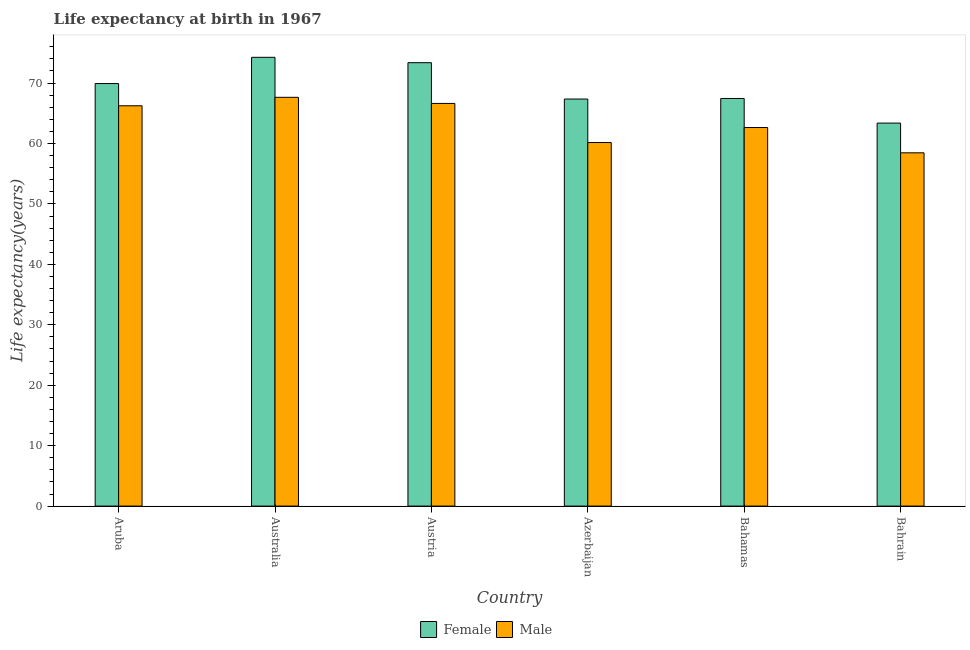How many groups of bars are there?
Offer a terse response. 6. Are the number of bars on each tick of the X-axis equal?
Your response must be concise. Yes. How many bars are there on the 6th tick from the right?
Your response must be concise. 2. What is the label of the 1st group of bars from the left?
Offer a very short reply. Aruba. What is the life expectancy(female) in Austria?
Give a very brief answer. 73.37. Across all countries, what is the maximum life expectancy(male)?
Make the answer very short. 67.64. Across all countries, what is the minimum life expectancy(male)?
Provide a short and direct response. 58.46. In which country was the life expectancy(male) maximum?
Ensure brevity in your answer.  Australia. In which country was the life expectancy(female) minimum?
Keep it short and to the point. Bahrain. What is the total life expectancy(female) in the graph?
Provide a succinct answer. 415.73. What is the difference between the life expectancy(female) in Austria and that in Azerbaijan?
Keep it short and to the point. 6.02. What is the difference between the life expectancy(male) in Aruba and the life expectancy(female) in Austria?
Provide a succinct answer. -7.13. What is the average life expectancy(male) per country?
Provide a succinct answer. 63.63. What is the difference between the life expectancy(female) and life expectancy(male) in Bahamas?
Provide a succinct answer. 4.81. In how many countries, is the life expectancy(female) greater than 34 years?
Your response must be concise. 6. What is the ratio of the life expectancy(female) in Austria to that in Azerbaijan?
Ensure brevity in your answer.  1.09. Is the difference between the life expectancy(female) in Azerbaijan and Bahamas greater than the difference between the life expectancy(male) in Azerbaijan and Bahamas?
Make the answer very short. Yes. What is the difference between the highest and the second highest life expectancy(female)?
Keep it short and to the point. 0.89. What is the difference between the highest and the lowest life expectancy(male)?
Keep it short and to the point. 9.18. In how many countries, is the life expectancy(male) greater than the average life expectancy(male) taken over all countries?
Offer a very short reply. 3. Is the sum of the life expectancy(male) in Aruba and Bahamas greater than the maximum life expectancy(female) across all countries?
Keep it short and to the point. Yes. How many bars are there?
Your answer should be compact. 12. How many countries are there in the graph?
Provide a succinct answer. 6. Does the graph contain any zero values?
Provide a succinct answer. No. Where does the legend appear in the graph?
Make the answer very short. Bottom center. How are the legend labels stacked?
Your answer should be very brief. Horizontal. What is the title of the graph?
Make the answer very short. Life expectancy at birth in 1967. What is the label or title of the X-axis?
Your answer should be very brief. Country. What is the label or title of the Y-axis?
Provide a succinct answer. Life expectancy(years). What is the Life expectancy(years) in Female in Aruba?
Keep it short and to the point. 69.92. What is the Life expectancy(years) of Male in Aruba?
Provide a short and direct response. 66.24. What is the Life expectancy(years) of Female in Australia?
Give a very brief answer. 74.26. What is the Life expectancy(years) in Male in Australia?
Ensure brevity in your answer.  67.64. What is the Life expectancy(years) of Female in Austria?
Provide a succinct answer. 73.37. What is the Life expectancy(years) in Male in Austria?
Your answer should be very brief. 66.63. What is the Life expectancy(years) in Female in Azerbaijan?
Ensure brevity in your answer.  67.36. What is the Life expectancy(years) in Male in Azerbaijan?
Provide a succinct answer. 60.16. What is the Life expectancy(years) in Female in Bahamas?
Make the answer very short. 67.45. What is the Life expectancy(years) in Male in Bahamas?
Your answer should be very brief. 62.64. What is the Life expectancy(years) in Female in Bahrain?
Your answer should be compact. 63.38. What is the Life expectancy(years) of Male in Bahrain?
Your response must be concise. 58.46. Across all countries, what is the maximum Life expectancy(years) of Female?
Offer a very short reply. 74.26. Across all countries, what is the maximum Life expectancy(years) of Male?
Your answer should be compact. 67.64. Across all countries, what is the minimum Life expectancy(years) in Female?
Ensure brevity in your answer.  63.38. Across all countries, what is the minimum Life expectancy(years) of Male?
Provide a succinct answer. 58.46. What is the total Life expectancy(years) of Female in the graph?
Make the answer very short. 415.73. What is the total Life expectancy(years) of Male in the graph?
Offer a terse response. 381.77. What is the difference between the Life expectancy(years) of Female in Aruba and that in Australia?
Offer a very short reply. -4.34. What is the difference between the Life expectancy(years) in Male in Aruba and that in Australia?
Make the answer very short. -1.4. What is the difference between the Life expectancy(years) of Female in Aruba and that in Austria?
Ensure brevity in your answer.  -3.45. What is the difference between the Life expectancy(years) in Male in Aruba and that in Austria?
Provide a succinct answer. -0.39. What is the difference between the Life expectancy(years) in Female in Aruba and that in Azerbaijan?
Your response must be concise. 2.56. What is the difference between the Life expectancy(years) of Male in Aruba and that in Azerbaijan?
Offer a very short reply. 6.08. What is the difference between the Life expectancy(years) in Female in Aruba and that in Bahamas?
Offer a terse response. 2.47. What is the difference between the Life expectancy(years) of Male in Aruba and that in Bahamas?
Provide a succinct answer. 3.6. What is the difference between the Life expectancy(years) in Female in Aruba and that in Bahrain?
Your answer should be compact. 6.54. What is the difference between the Life expectancy(years) of Male in Aruba and that in Bahrain?
Offer a terse response. 7.78. What is the difference between the Life expectancy(years) of Female in Australia and that in Austria?
Give a very brief answer. 0.89. What is the difference between the Life expectancy(years) of Female in Australia and that in Azerbaijan?
Provide a short and direct response. 6.91. What is the difference between the Life expectancy(years) of Male in Australia and that in Azerbaijan?
Your answer should be compact. 7.48. What is the difference between the Life expectancy(years) of Female in Australia and that in Bahamas?
Your answer should be very brief. 6.81. What is the difference between the Life expectancy(years) in Male in Australia and that in Bahamas?
Make the answer very short. 5. What is the difference between the Life expectancy(years) in Female in Australia and that in Bahrain?
Offer a terse response. 10.88. What is the difference between the Life expectancy(years) in Male in Australia and that in Bahrain?
Keep it short and to the point. 9.18. What is the difference between the Life expectancy(years) of Female in Austria and that in Azerbaijan?
Give a very brief answer. 6.01. What is the difference between the Life expectancy(years) in Male in Austria and that in Azerbaijan?
Your response must be concise. 6.47. What is the difference between the Life expectancy(years) of Female in Austria and that in Bahamas?
Ensure brevity in your answer.  5.92. What is the difference between the Life expectancy(years) in Male in Austria and that in Bahamas?
Offer a terse response. 3.99. What is the difference between the Life expectancy(years) in Female in Austria and that in Bahrain?
Your answer should be compact. 9.99. What is the difference between the Life expectancy(years) in Male in Austria and that in Bahrain?
Your answer should be very brief. 8.17. What is the difference between the Life expectancy(years) of Female in Azerbaijan and that in Bahamas?
Your response must be concise. -0.09. What is the difference between the Life expectancy(years) of Male in Azerbaijan and that in Bahamas?
Provide a succinct answer. -2.48. What is the difference between the Life expectancy(years) in Female in Azerbaijan and that in Bahrain?
Provide a short and direct response. 3.98. What is the difference between the Life expectancy(years) of Female in Bahamas and that in Bahrain?
Your response must be concise. 4.07. What is the difference between the Life expectancy(years) of Male in Bahamas and that in Bahrain?
Offer a terse response. 4.18. What is the difference between the Life expectancy(years) in Female in Aruba and the Life expectancy(years) in Male in Australia?
Your response must be concise. 2.28. What is the difference between the Life expectancy(years) of Female in Aruba and the Life expectancy(years) of Male in Austria?
Give a very brief answer. 3.29. What is the difference between the Life expectancy(years) of Female in Aruba and the Life expectancy(years) of Male in Azerbaijan?
Provide a succinct answer. 9.76. What is the difference between the Life expectancy(years) of Female in Aruba and the Life expectancy(years) of Male in Bahamas?
Provide a succinct answer. 7.27. What is the difference between the Life expectancy(years) of Female in Aruba and the Life expectancy(years) of Male in Bahrain?
Offer a terse response. 11.46. What is the difference between the Life expectancy(years) in Female in Australia and the Life expectancy(years) in Male in Austria?
Offer a terse response. 7.63. What is the difference between the Life expectancy(years) in Female in Australia and the Life expectancy(years) in Male in Azerbaijan?
Ensure brevity in your answer.  14.1. What is the difference between the Life expectancy(years) in Female in Australia and the Life expectancy(years) in Male in Bahamas?
Provide a succinct answer. 11.62. What is the difference between the Life expectancy(years) of Female in Australia and the Life expectancy(years) of Male in Bahrain?
Your response must be concise. 15.8. What is the difference between the Life expectancy(years) in Female in Austria and the Life expectancy(years) in Male in Azerbaijan?
Your answer should be very brief. 13.21. What is the difference between the Life expectancy(years) of Female in Austria and the Life expectancy(years) of Male in Bahamas?
Make the answer very short. 10.73. What is the difference between the Life expectancy(years) in Female in Austria and the Life expectancy(years) in Male in Bahrain?
Provide a short and direct response. 14.91. What is the difference between the Life expectancy(years) of Female in Azerbaijan and the Life expectancy(years) of Male in Bahamas?
Keep it short and to the point. 4.71. What is the difference between the Life expectancy(years) in Female in Azerbaijan and the Life expectancy(years) in Male in Bahrain?
Ensure brevity in your answer.  8.9. What is the difference between the Life expectancy(years) in Female in Bahamas and the Life expectancy(years) in Male in Bahrain?
Make the answer very short. 8.99. What is the average Life expectancy(years) of Female per country?
Give a very brief answer. 69.29. What is the average Life expectancy(years) of Male per country?
Provide a succinct answer. 63.63. What is the difference between the Life expectancy(years) in Female and Life expectancy(years) in Male in Aruba?
Make the answer very short. 3.67. What is the difference between the Life expectancy(years) of Female and Life expectancy(years) of Male in Australia?
Offer a terse response. 6.62. What is the difference between the Life expectancy(years) in Female and Life expectancy(years) in Male in Austria?
Keep it short and to the point. 6.74. What is the difference between the Life expectancy(years) in Female and Life expectancy(years) in Male in Azerbaijan?
Offer a terse response. 7.2. What is the difference between the Life expectancy(years) in Female and Life expectancy(years) in Male in Bahamas?
Provide a short and direct response. 4.81. What is the difference between the Life expectancy(years) in Female and Life expectancy(years) in Male in Bahrain?
Keep it short and to the point. 4.92. What is the ratio of the Life expectancy(years) of Female in Aruba to that in Australia?
Ensure brevity in your answer.  0.94. What is the ratio of the Life expectancy(years) of Male in Aruba to that in Australia?
Your answer should be compact. 0.98. What is the ratio of the Life expectancy(years) of Female in Aruba to that in Austria?
Your answer should be very brief. 0.95. What is the ratio of the Life expectancy(years) of Female in Aruba to that in Azerbaijan?
Provide a succinct answer. 1.04. What is the ratio of the Life expectancy(years) of Male in Aruba to that in Azerbaijan?
Your response must be concise. 1.1. What is the ratio of the Life expectancy(years) of Female in Aruba to that in Bahamas?
Provide a short and direct response. 1.04. What is the ratio of the Life expectancy(years) of Male in Aruba to that in Bahamas?
Your answer should be compact. 1.06. What is the ratio of the Life expectancy(years) in Female in Aruba to that in Bahrain?
Provide a short and direct response. 1.1. What is the ratio of the Life expectancy(years) in Male in Aruba to that in Bahrain?
Make the answer very short. 1.13. What is the ratio of the Life expectancy(years) in Female in Australia to that in Austria?
Provide a short and direct response. 1.01. What is the ratio of the Life expectancy(years) in Male in Australia to that in Austria?
Give a very brief answer. 1.02. What is the ratio of the Life expectancy(years) in Female in Australia to that in Azerbaijan?
Your answer should be compact. 1.1. What is the ratio of the Life expectancy(years) in Male in Australia to that in Azerbaijan?
Ensure brevity in your answer.  1.12. What is the ratio of the Life expectancy(years) in Female in Australia to that in Bahamas?
Give a very brief answer. 1.1. What is the ratio of the Life expectancy(years) in Male in Australia to that in Bahamas?
Your answer should be compact. 1.08. What is the ratio of the Life expectancy(years) in Female in Australia to that in Bahrain?
Your answer should be compact. 1.17. What is the ratio of the Life expectancy(years) of Male in Australia to that in Bahrain?
Your response must be concise. 1.16. What is the ratio of the Life expectancy(years) of Female in Austria to that in Azerbaijan?
Make the answer very short. 1.09. What is the ratio of the Life expectancy(years) of Male in Austria to that in Azerbaijan?
Offer a terse response. 1.11. What is the ratio of the Life expectancy(years) of Female in Austria to that in Bahamas?
Ensure brevity in your answer.  1.09. What is the ratio of the Life expectancy(years) of Male in Austria to that in Bahamas?
Offer a very short reply. 1.06. What is the ratio of the Life expectancy(years) of Female in Austria to that in Bahrain?
Make the answer very short. 1.16. What is the ratio of the Life expectancy(years) of Male in Austria to that in Bahrain?
Provide a short and direct response. 1.14. What is the ratio of the Life expectancy(years) of Female in Azerbaijan to that in Bahamas?
Provide a short and direct response. 1. What is the ratio of the Life expectancy(years) of Male in Azerbaijan to that in Bahamas?
Make the answer very short. 0.96. What is the ratio of the Life expectancy(years) of Female in Azerbaijan to that in Bahrain?
Give a very brief answer. 1.06. What is the ratio of the Life expectancy(years) in Male in Azerbaijan to that in Bahrain?
Make the answer very short. 1.03. What is the ratio of the Life expectancy(years) in Female in Bahamas to that in Bahrain?
Your answer should be very brief. 1.06. What is the ratio of the Life expectancy(years) of Male in Bahamas to that in Bahrain?
Ensure brevity in your answer.  1.07. What is the difference between the highest and the second highest Life expectancy(years) in Female?
Provide a succinct answer. 0.89. What is the difference between the highest and the lowest Life expectancy(years) of Female?
Give a very brief answer. 10.88. What is the difference between the highest and the lowest Life expectancy(years) of Male?
Provide a short and direct response. 9.18. 